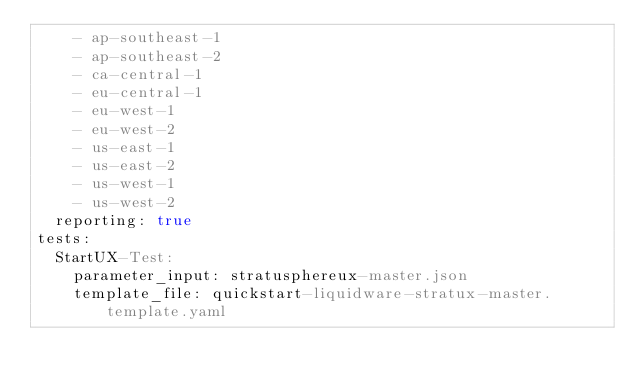<code> <loc_0><loc_0><loc_500><loc_500><_YAML_>    - ap-southeast-1
    - ap-southeast-2
    - ca-central-1
    - eu-central-1
    - eu-west-1
    - eu-west-2
    - us-east-1
    - us-east-2
    - us-west-1
    - us-west-2
  reporting: true
tests:
  StartUX-Test:
    parameter_input: stratusphereux-master.json
    template_file: quickstart-liquidware-stratux-master.template.yaml

</code> 